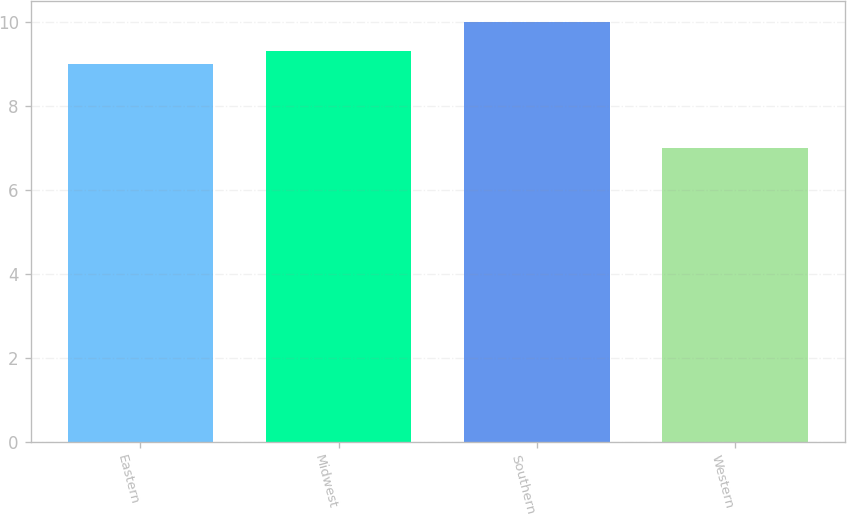Convert chart to OTSL. <chart><loc_0><loc_0><loc_500><loc_500><bar_chart><fcel>Eastern<fcel>Midwest<fcel>Southern<fcel>Western<nl><fcel>9<fcel>9.3<fcel>10<fcel>7<nl></chart> 